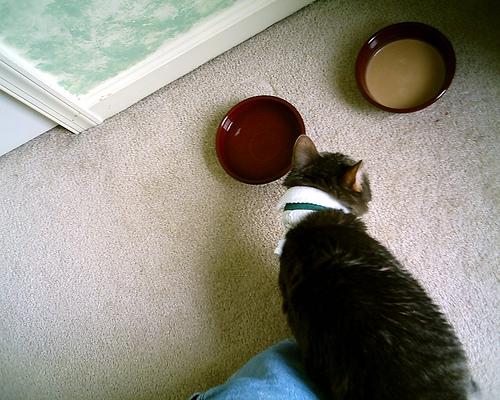What color is the cat's collar?
Write a very short answer. Green. How many dishes are for the cat?
Give a very brief answer. 2. What is in the left cat dish?
Answer briefly. Water. 